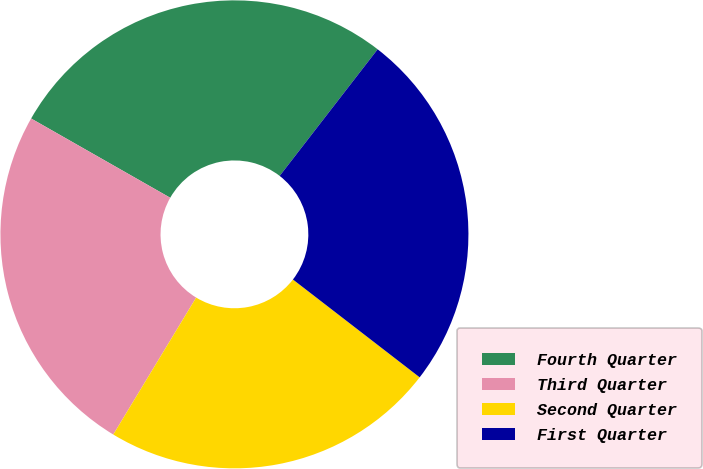Convert chart to OTSL. <chart><loc_0><loc_0><loc_500><loc_500><pie_chart><fcel>Fourth Quarter<fcel>Third Quarter<fcel>Second Quarter<fcel>First Quarter<nl><fcel>27.24%<fcel>24.58%<fcel>23.2%<fcel>24.98%<nl></chart> 